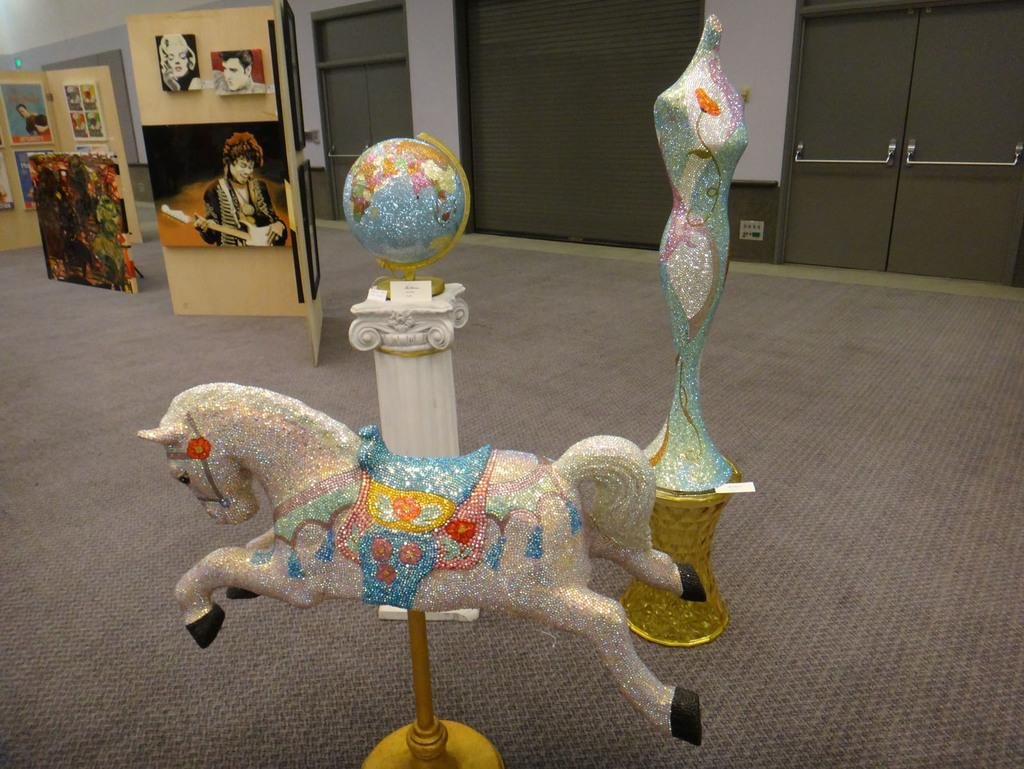What type of toy is present in the image? There is a toy horse in the image. What object related to geography can be seen in the image? There is a globe in the image. What artistic object is present in the image? There is a sculpture in the image. What items are used for displaying photos in the image? There are photo frames in the image. What architectural feature is visible in the image? There is a door visible in the image. How many faces can be seen on the toy horse in the image? There are no faces present on the toy horse in the image, as it is a toy and not a living creature. What action is the sculpture performing in the image? The sculpture is not performing any action in the image, as it is a static object. 